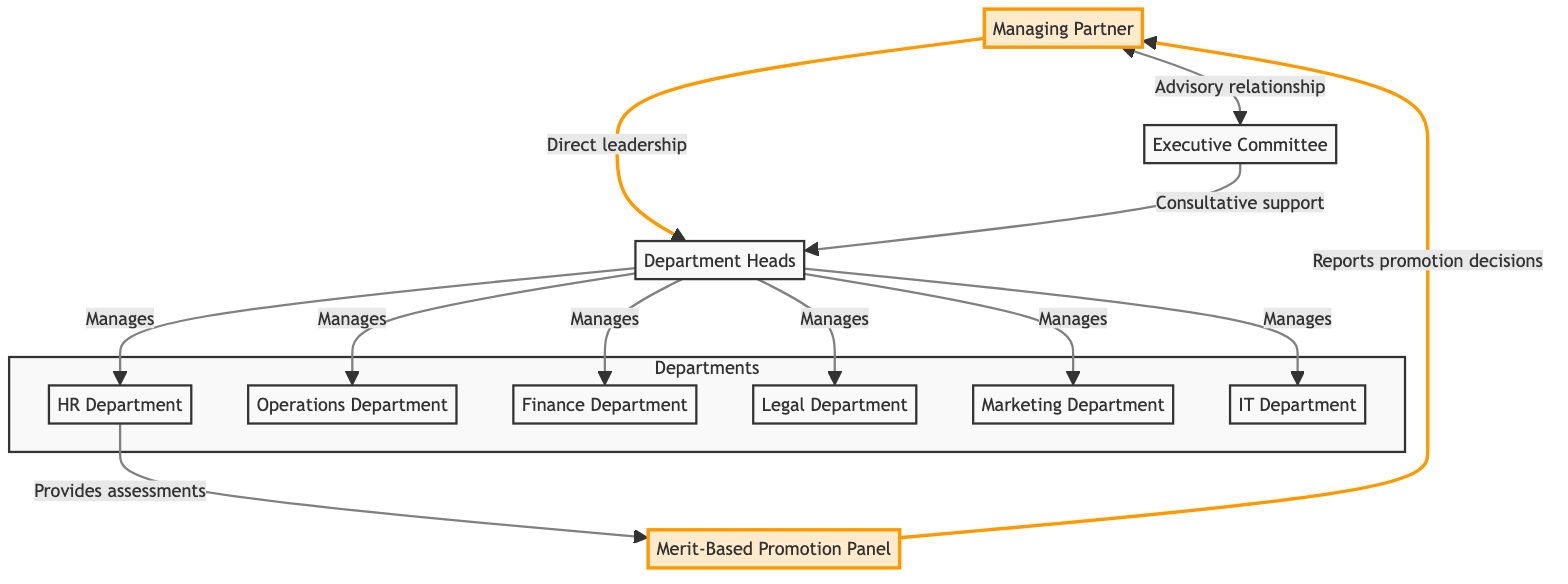What is the highest position in the organizational structure? The topmost node in the diagram is the Managing Partner, indicating that this is the highest role in the firm.
Answer: Managing Partner How many departments are managed by the Department Heads? There are six departments illustrated below the Department Heads in the diagram (HR, Operations, Finance, Legal, Marketing, IT). Therefore, the total is six.
Answer: 6 Which panel is responsible for promotion decisions? In the diagram, the Merit-Based Promotion Panel is the designated panel that handles promotion decisions, as it is directly connected to both HR Department and the Managing Partner.
Answer: Merit-Based Promotion Panel Who provides assessments to the Merit-Based Promotion Panel? The HR Department is specifically shown to provide assessments to the Merit-Based Promotion Panel, as indicated by the directional arrow linking both nodes.
Answer: HR Department What type of relationship exists between the Managing Partner and the Executive Committee? The diagram indicates an advisory relationship connecting the Managing Partner and the Executive Committee through a two-way arrow, defining the nature of their interaction.
Answer: Advisory relationship Which department does the Operations Department report to? The Operations Department reports directly to the Department Heads, as indicated by the directional link from the Department Heads to the Operations Department.
Answer: Department Heads How many nodes exist in the Departments subgraph? The subgraph contains six nodes, each representing a different department within the organizational structure, namely HR, Operations, Finance, Legal, Marketing, and IT.
Answer: 6 What is the relationship between the Executive Committee and the Department Heads? The diagram illustrates that the Executive Committee provides consultative support to the Department Heads, indicated by their one-way connection.
Answer: Consultative support What role does the Legal Department have within the firm? The Legal Department is one of the six departments managed by the Department Heads, indicating their role as a functional part of the organizational structure.
Answer: Managed by Department Heads 